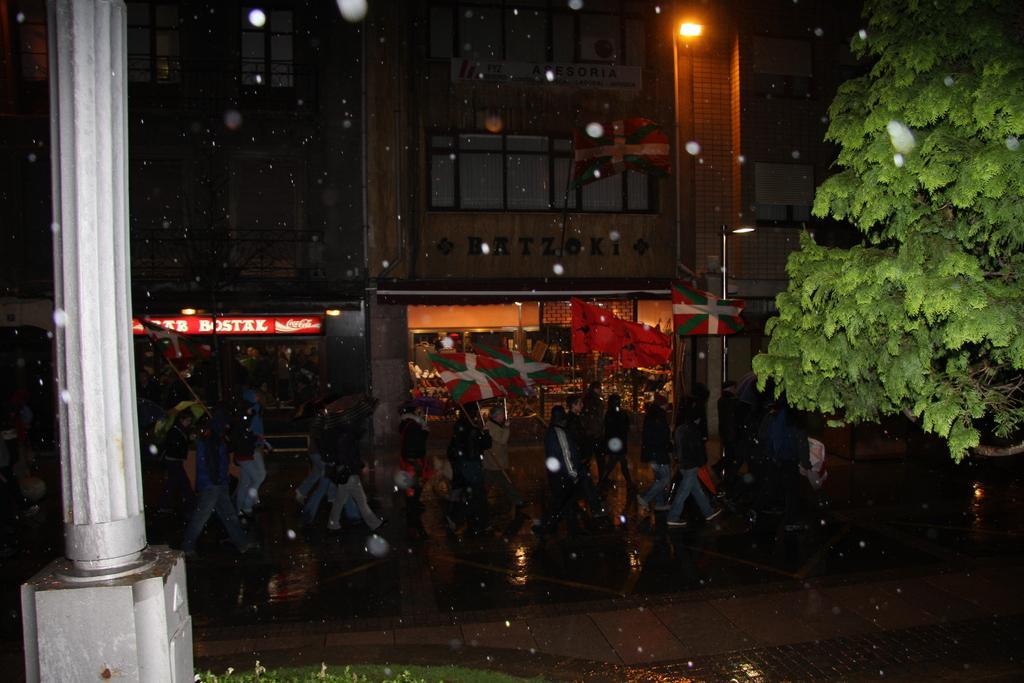Describe this image in one or two sentences. In this picture we can see some people are walking on the road, side we can see some shops, buildings and trees. 